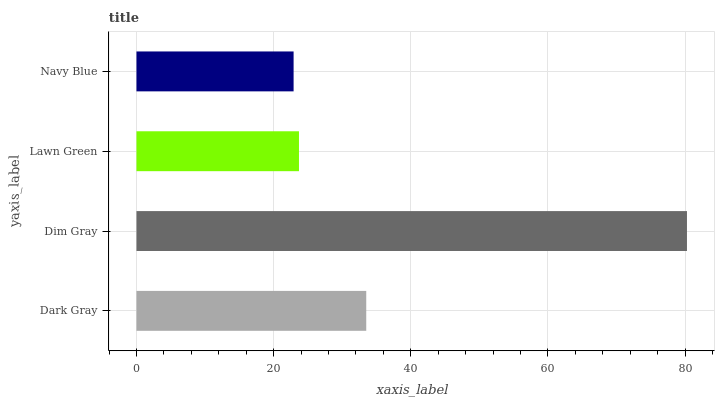Is Navy Blue the minimum?
Answer yes or no. Yes. Is Dim Gray the maximum?
Answer yes or no. Yes. Is Lawn Green the minimum?
Answer yes or no. No. Is Lawn Green the maximum?
Answer yes or no. No. Is Dim Gray greater than Lawn Green?
Answer yes or no. Yes. Is Lawn Green less than Dim Gray?
Answer yes or no. Yes. Is Lawn Green greater than Dim Gray?
Answer yes or no. No. Is Dim Gray less than Lawn Green?
Answer yes or no. No. Is Dark Gray the high median?
Answer yes or no. Yes. Is Lawn Green the low median?
Answer yes or no. Yes. Is Dim Gray the high median?
Answer yes or no. No. Is Dim Gray the low median?
Answer yes or no. No. 